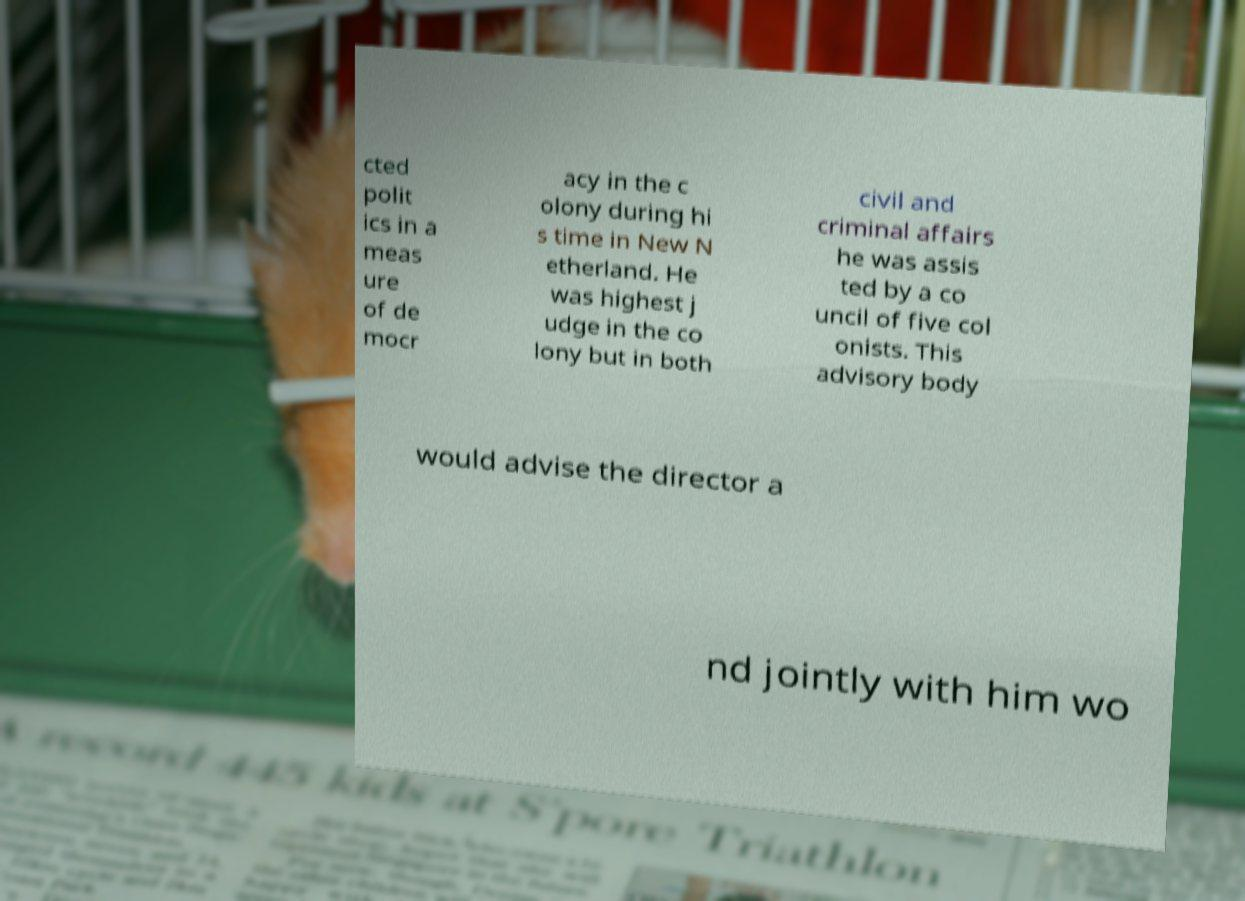What messages or text are displayed in this image? I need them in a readable, typed format. cted polit ics in a meas ure of de mocr acy in the c olony during hi s time in New N etherland. He was highest j udge in the co lony but in both civil and criminal affairs he was assis ted by a co uncil of five col onists. This advisory body would advise the director a nd jointly with him wo 